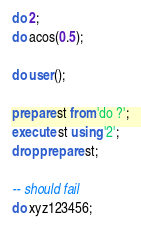<code> <loc_0><loc_0><loc_500><loc_500><_SQL_>do 2;
do acos(0.5);

do user();

prepare st from 'do ?';
execute st using '2';
drop prepare st;

-- should fail
do xyz123456;
</code> 